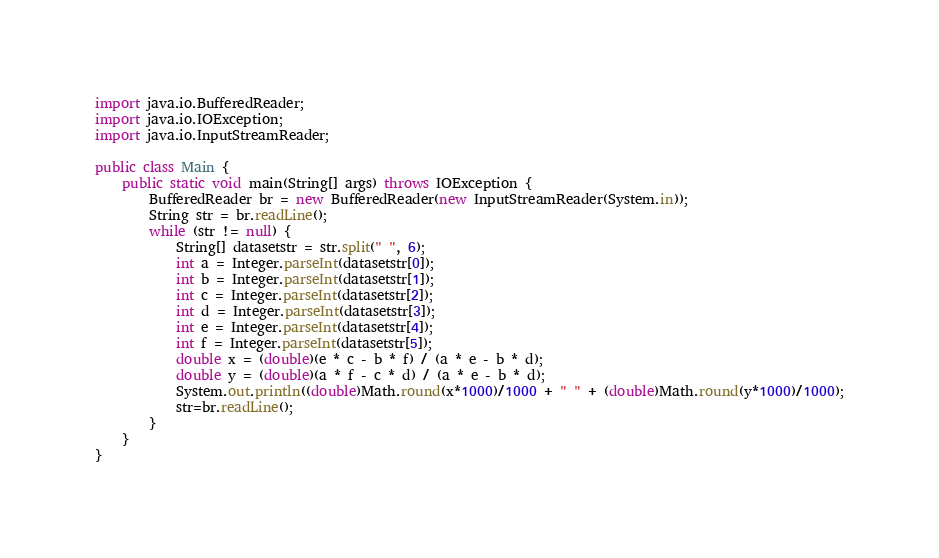<code> <loc_0><loc_0><loc_500><loc_500><_Java_>import java.io.BufferedReader;
import java.io.IOException;
import java.io.InputStreamReader;

public class Main {
	public static void main(String[] args) throws IOException {
		BufferedReader br = new BufferedReader(new InputStreamReader(System.in));
		String str = br.readLine();
		while (str != null) {
			String[] datasetstr = str.split(" ", 6);
			int a = Integer.parseInt(datasetstr[0]);
			int b = Integer.parseInt(datasetstr[1]);
			int c = Integer.parseInt(datasetstr[2]);
			int d = Integer.parseInt(datasetstr[3]);
			int e = Integer.parseInt(datasetstr[4]);
			int f = Integer.parseInt(datasetstr[5]);
			double x = (double)(e * c - b * f) / (a * e - b * d);
			double y = (double)(a * f - c * d) / (a * e - b * d);
			System.out.println((double)Math.round(x*1000)/1000 + " " + (double)Math.round(y*1000)/1000);
			str=br.readLine();
		}
	}
}</code> 